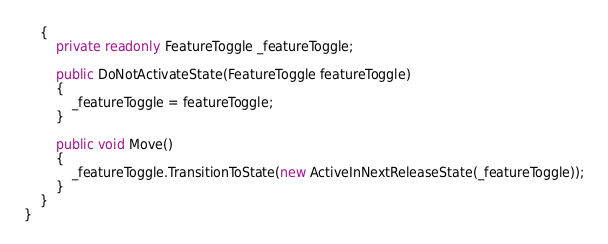<code> <loc_0><loc_0><loc_500><loc_500><_C#_>    {
        private readonly FeatureToggle _featureToggle;

        public DoNotActivateState(FeatureToggle featureToggle)
        {
            _featureToggle = featureToggle;
        }
        
        public void Move()
        {
            _featureToggle.TransitionToState(new ActiveInNextReleaseState(_featureToggle));
        }
    }
}</code> 